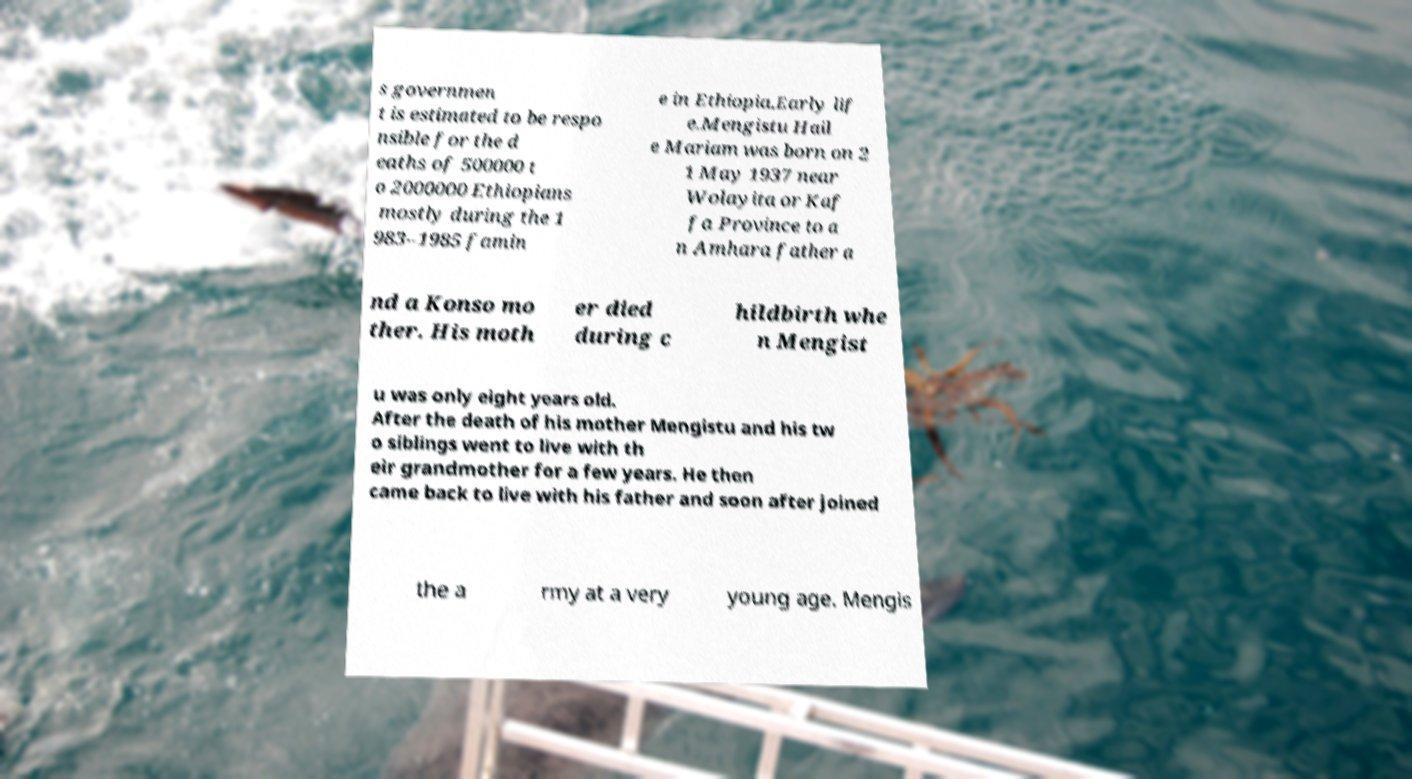What messages or text are displayed in this image? I need them in a readable, typed format. s governmen t is estimated to be respo nsible for the d eaths of 500000 t o 2000000 Ethiopians mostly during the 1 983–1985 famin e in Ethiopia.Early lif e.Mengistu Hail e Mariam was born on 2 1 May 1937 near Wolayita or Kaf fa Province to a n Amhara father a nd a Konso mo ther. His moth er died during c hildbirth whe n Mengist u was only eight years old. After the death of his mother Mengistu and his tw o siblings went to live with th eir grandmother for a few years. He then came back to live with his father and soon after joined the a rmy at a very young age. Mengis 